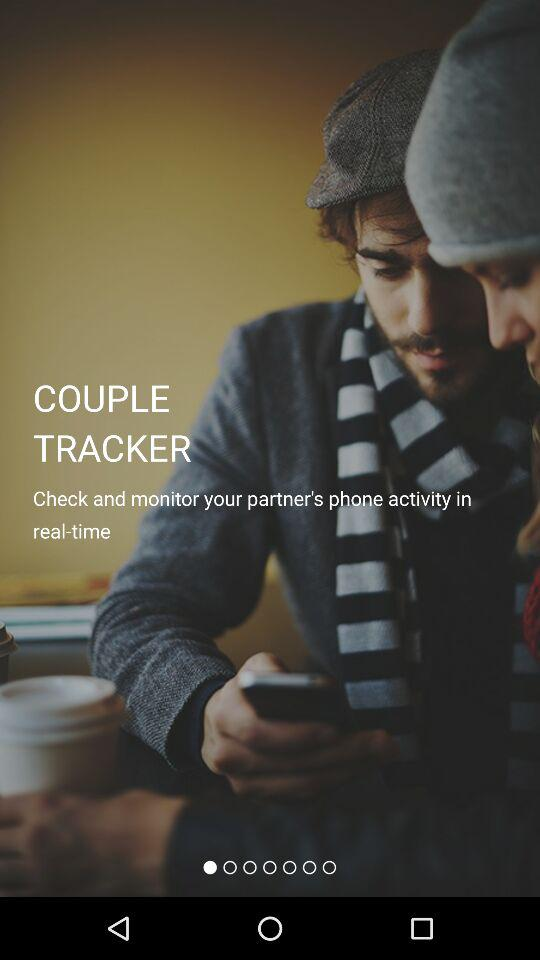When was the application copyrighted?
When the provided information is insufficient, respond with <no answer>. <no answer> 